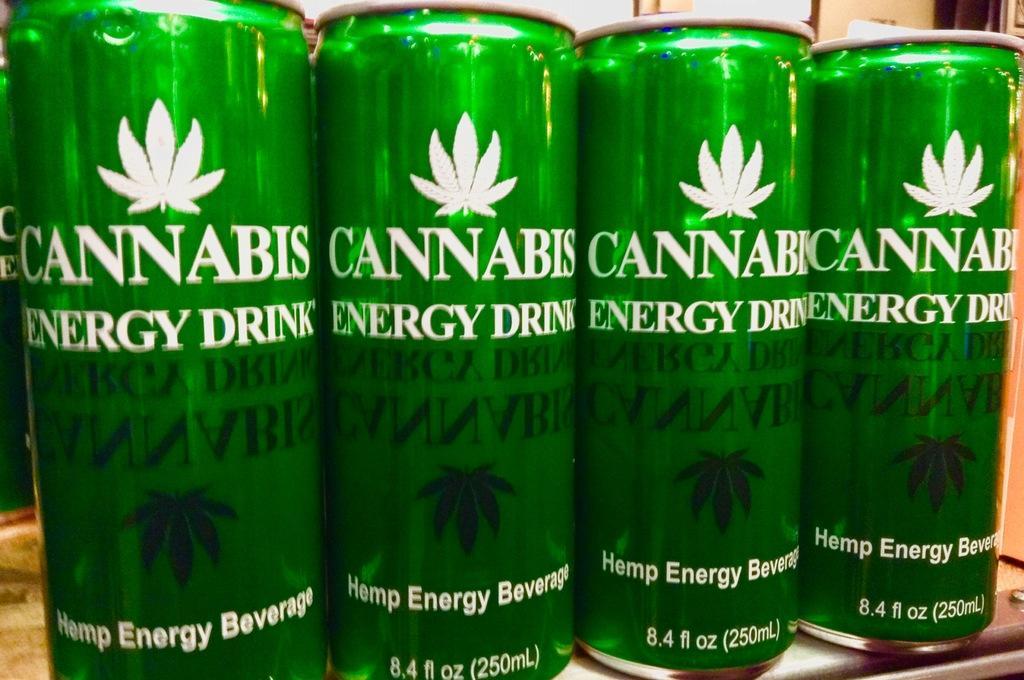Please provide a concise description of this image. In this image we can see some green color tins on the table, on the things, we can see some text and in the background, it looks like the wall. 